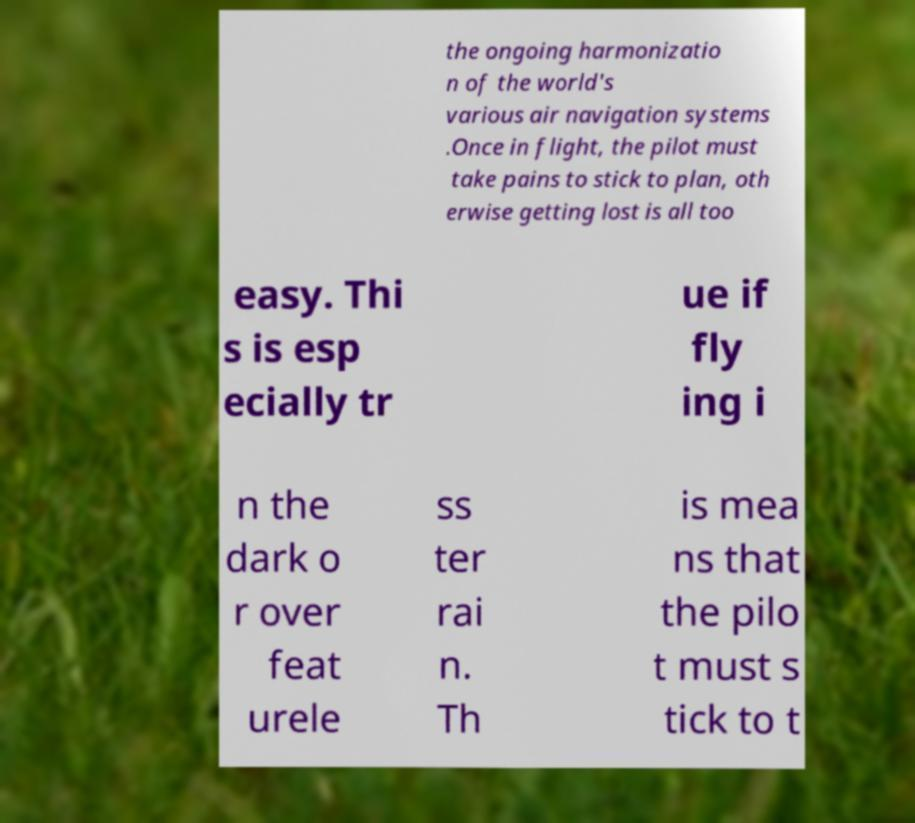Please read and relay the text visible in this image. What does it say? the ongoing harmonizatio n of the world's various air navigation systems .Once in flight, the pilot must take pains to stick to plan, oth erwise getting lost is all too easy. Thi s is esp ecially tr ue if fly ing i n the dark o r over feat urele ss ter rai n. Th is mea ns that the pilo t must s tick to t 